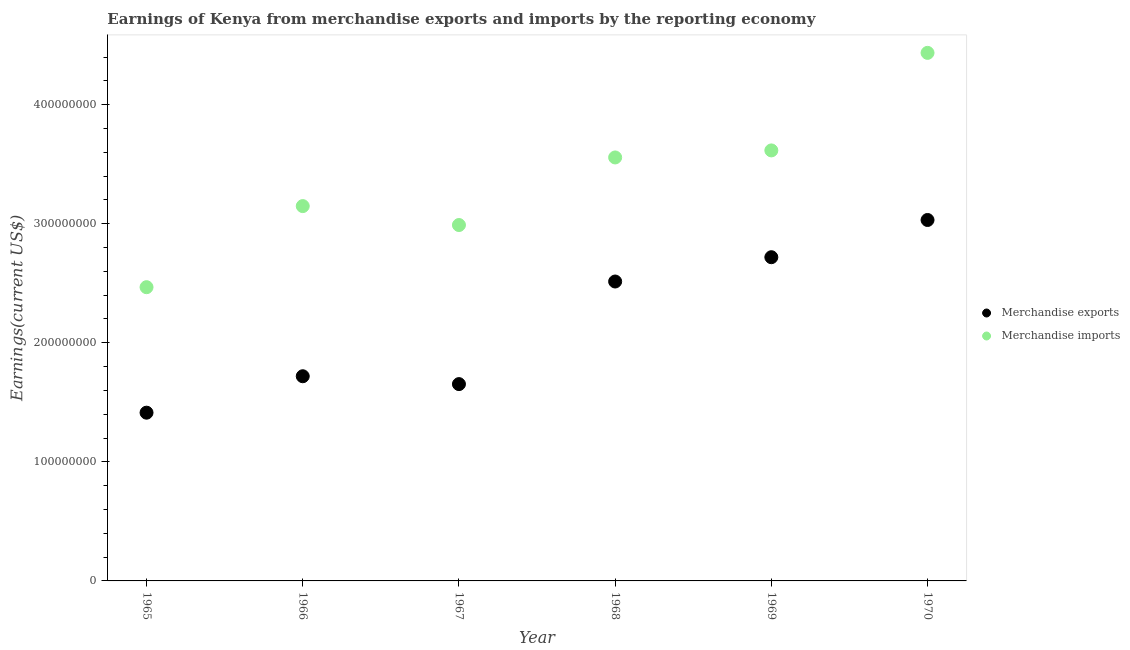Is the number of dotlines equal to the number of legend labels?
Ensure brevity in your answer.  Yes. What is the earnings from merchandise imports in 1965?
Give a very brief answer. 2.47e+08. Across all years, what is the maximum earnings from merchandise exports?
Keep it short and to the point. 3.03e+08. Across all years, what is the minimum earnings from merchandise imports?
Provide a short and direct response. 2.47e+08. In which year was the earnings from merchandise exports maximum?
Keep it short and to the point. 1970. In which year was the earnings from merchandise imports minimum?
Give a very brief answer. 1965. What is the total earnings from merchandise exports in the graph?
Keep it short and to the point. 1.30e+09. What is the difference between the earnings from merchandise imports in 1968 and that in 1970?
Provide a short and direct response. -8.78e+07. What is the difference between the earnings from merchandise imports in 1966 and the earnings from merchandise exports in 1965?
Make the answer very short. 1.74e+08. What is the average earnings from merchandise exports per year?
Offer a very short reply. 2.17e+08. In the year 1966, what is the difference between the earnings from merchandise exports and earnings from merchandise imports?
Offer a very short reply. -1.43e+08. In how many years, is the earnings from merchandise exports greater than 140000000 US$?
Provide a short and direct response. 6. What is the ratio of the earnings from merchandise exports in 1965 to that in 1966?
Give a very brief answer. 0.82. Is the earnings from merchandise imports in 1967 less than that in 1970?
Keep it short and to the point. Yes. What is the difference between the highest and the second highest earnings from merchandise exports?
Give a very brief answer. 3.13e+07. What is the difference between the highest and the lowest earnings from merchandise imports?
Keep it short and to the point. 1.97e+08. In how many years, is the earnings from merchandise imports greater than the average earnings from merchandise imports taken over all years?
Your answer should be very brief. 3. Does the earnings from merchandise imports monotonically increase over the years?
Offer a terse response. No. How many dotlines are there?
Offer a terse response. 2. What is the difference between two consecutive major ticks on the Y-axis?
Your answer should be very brief. 1.00e+08. Are the values on the major ticks of Y-axis written in scientific E-notation?
Provide a succinct answer. No. What is the title of the graph?
Your answer should be very brief. Earnings of Kenya from merchandise exports and imports by the reporting economy. What is the label or title of the Y-axis?
Ensure brevity in your answer.  Earnings(current US$). What is the Earnings(current US$) of Merchandise exports in 1965?
Offer a very short reply. 1.41e+08. What is the Earnings(current US$) of Merchandise imports in 1965?
Make the answer very short. 2.47e+08. What is the Earnings(current US$) in Merchandise exports in 1966?
Give a very brief answer. 1.72e+08. What is the Earnings(current US$) in Merchandise imports in 1966?
Your answer should be compact. 3.15e+08. What is the Earnings(current US$) in Merchandise exports in 1967?
Provide a succinct answer. 1.65e+08. What is the Earnings(current US$) of Merchandise imports in 1967?
Offer a terse response. 2.99e+08. What is the Earnings(current US$) of Merchandise exports in 1968?
Offer a very short reply. 2.51e+08. What is the Earnings(current US$) of Merchandise imports in 1968?
Your answer should be compact. 3.56e+08. What is the Earnings(current US$) of Merchandise exports in 1969?
Ensure brevity in your answer.  2.72e+08. What is the Earnings(current US$) in Merchandise imports in 1969?
Give a very brief answer. 3.62e+08. What is the Earnings(current US$) in Merchandise exports in 1970?
Ensure brevity in your answer.  3.03e+08. What is the Earnings(current US$) in Merchandise imports in 1970?
Offer a very short reply. 4.43e+08. Across all years, what is the maximum Earnings(current US$) of Merchandise exports?
Provide a succinct answer. 3.03e+08. Across all years, what is the maximum Earnings(current US$) in Merchandise imports?
Provide a short and direct response. 4.43e+08. Across all years, what is the minimum Earnings(current US$) in Merchandise exports?
Your answer should be compact. 1.41e+08. Across all years, what is the minimum Earnings(current US$) in Merchandise imports?
Provide a succinct answer. 2.47e+08. What is the total Earnings(current US$) in Merchandise exports in the graph?
Ensure brevity in your answer.  1.30e+09. What is the total Earnings(current US$) of Merchandise imports in the graph?
Keep it short and to the point. 2.02e+09. What is the difference between the Earnings(current US$) in Merchandise exports in 1965 and that in 1966?
Provide a succinct answer. -3.06e+07. What is the difference between the Earnings(current US$) of Merchandise imports in 1965 and that in 1966?
Your answer should be compact. -6.81e+07. What is the difference between the Earnings(current US$) of Merchandise exports in 1965 and that in 1967?
Provide a short and direct response. -2.40e+07. What is the difference between the Earnings(current US$) in Merchandise imports in 1965 and that in 1967?
Give a very brief answer. -5.22e+07. What is the difference between the Earnings(current US$) of Merchandise exports in 1965 and that in 1968?
Keep it short and to the point. -1.10e+08. What is the difference between the Earnings(current US$) of Merchandise imports in 1965 and that in 1968?
Your response must be concise. -1.09e+08. What is the difference between the Earnings(current US$) of Merchandise exports in 1965 and that in 1969?
Your answer should be very brief. -1.31e+08. What is the difference between the Earnings(current US$) of Merchandise imports in 1965 and that in 1969?
Ensure brevity in your answer.  -1.15e+08. What is the difference between the Earnings(current US$) in Merchandise exports in 1965 and that in 1970?
Make the answer very short. -1.62e+08. What is the difference between the Earnings(current US$) of Merchandise imports in 1965 and that in 1970?
Your response must be concise. -1.97e+08. What is the difference between the Earnings(current US$) of Merchandise exports in 1966 and that in 1967?
Give a very brief answer. 6.60e+06. What is the difference between the Earnings(current US$) in Merchandise imports in 1966 and that in 1967?
Give a very brief answer. 1.59e+07. What is the difference between the Earnings(current US$) of Merchandise exports in 1966 and that in 1968?
Provide a short and direct response. -7.96e+07. What is the difference between the Earnings(current US$) of Merchandise imports in 1966 and that in 1968?
Your response must be concise. -4.09e+07. What is the difference between the Earnings(current US$) in Merchandise exports in 1966 and that in 1969?
Make the answer very short. -1.00e+08. What is the difference between the Earnings(current US$) in Merchandise imports in 1966 and that in 1969?
Make the answer very short. -4.68e+07. What is the difference between the Earnings(current US$) of Merchandise exports in 1966 and that in 1970?
Ensure brevity in your answer.  -1.31e+08. What is the difference between the Earnings(current US$) of Merchandise imports in 1966 and that in 1970?
Your response must be concise. -1.29e+08. What is the difference between the Earnings(current US$) of Merchandise exports in 1967 and that in 1968?
Offer a terse response. -8.62e+07. What is the difference between the Earnings(current US$) of Merchandise imports in 1967 and that in 1968?
Offer a very short reply. -5.68e+07. What is the difference between the Earnings(current US$) of Merchandise exports in 1967 and that in 1969?
Make the answer very short. -1.07e+08. What is the difference between the Earnings(current US$) of Merchandise imports in 1967 and that in 1969?
Offer a very short reply. -6.27e+07. What is the difference between the Earnings(current US$) of Merchandise exports in 1967 and that in 1970?
Offer a very short reply. -1.38e+08. What is the difference between the Earnings(current US$) of Merchandise imports in 1967 and that in 1970?
Your response must be concise. -1.45e+08. What is the difference between the Earnings(current US$) in Merchandise exports in 1968 and that in 1969?
Provide a short and direct response. -2.04e+07. What is the difference between the Earnings(current US$) of Merchandise imports in 1968 and that in 1969?
Provide a succinct answer. -5.91e+06. What is the difference between the Earnings(current US$) of Merchandise exports in 1968 and that in 1970?
Your response must be concise. -5.17e+07. What is the difference between the Earnings(current US$) of Merchandise imports in 1968 and that in 1970?
Keep it short and to the point. -8.78e+07. What is the difference between the Earnings(current US$) of Merchandise exports in 1969 and that in 1970?
Keep it short and to the point. -3.13e+07. What is the difference between the Earnings(current US$) in Merchandise imports in 1969 and that in 1970?
Your answer should be compact. -8.19e+07. What is the difference between the Earnings(current US$) of Merchandise exports in 1965 and the Earnings(current US$) of Merchandise imports in 1966?
Your answer should be compact. -1.74e+08. What is the difference between the Earnings(current US$) of Merchandise exports in 1965 and the Earnings(current US$) of Merchandise imports in 1967?
Give a very brief answer. -1.58e+08. What is the difference between the Earnings(current US$) of Merchandise exports in 1965 and the Earnings(current US$) of Merchandise imports in 1968?
Make the answer very short. -2.14e+08. What is the difference between the Earnings(current US$) in Merchandise exports in 1965 and the Earnings(current US$) in Merchandise imports in 1969?
Ensure brevity in your answer.  -2.20e+08. What is the difference between the Earnings(current US$) of Merchandise exports in 1965 and the Earnings(current US$) of Merchandise imports in 1970?
Your answer should be very brief. -3.02e+08. What is the difference between the Earnings(current US$) in Merchandise exports in 1966 and the Earnings(current US$) in Merchandise imports in 1967?
Your response must be concise. -1.27e+08. What is the difference between the Earnings(current US$) of Merchandise exports in 1966 and the Earnings(current US$) of Merchandise imports in 1968?
Provide a short and direct response. -1.84e+08. What is the difference between the Earnings(current US$) of Merchandise exports in 1966 and the Earnings(current US$) of Merchandise imports in 1969?
Provide a succinct answer. -1.90e+08. What is the difference between the Earnings(current US$) of Merchandise exports in 1966 and the Earnings(current US$) of Merchandise imports in 1970?
Your answer should be very brief. -2.72e+08. What is the difference between the Earnings(current US$) of Merchandise exports in 1967 and the Earnings(current US$) of Merchandise imports in 1968?
Make the answer very short. -1.90e+08. What is the difference between the Earnings(current US$) in Merchandise exports in 1967 and the Earnings(current US$) in Merchandise imports in 1969?
Keep it short and to the point. -1.96e+08. What is the difference between the Earnings(current US$) in Merchandise exports in 1967 and the Earnings(current US$) in Merchandise imports in 1970?
Your response must be concise. -2.78e+08. What is the difference between the Earnings(current US$) in Merchandise exports in 1968 and the Earnings(current US$) in Merchandise imports in 1969?
Your response must be concise. -1.10e+08. What is the difference between the Earnings(current US$) of Merchandise exports in 1968 and the Earnings(current US$) of Merchandise imports in 1970?
Ensure brevity in your answer.  -1.92e+08. What is the difference between the Earnings(current US$) of Merchandise exports in 1969 and the Earnings(current US$) of Merchandise imports in 1970?
Provide a short and direct response. -1.72e+08. What is the average Earnings(current US$) of Merchandise exports per year?
Give a very brief answer. 2.17e+08. What is the average Earnings(current US$) of Merchandise imports per year?
Provide a succinct answer. 3.37e+08. In the year 1965, what is the difference between the Earnings(current US$) in Merchandise exports and Earnings(current US$) in Merchandise imports?
Keep it short and to the point. -1.05e+08. In the year 1966, what is the difference between the Earnings(current US$) in Merchandise exports and Earnings(current US$) in Merchandise imports?
Offer a very short reply. -1.43e+08. In the year 1967, what is the difference between the Earnings(current US$) of Merchandise exports and Earnings(current US$) of Merchandise imports?
Offer a very short reply. -1.34e+08. In the year 1968, what is the difference between the Earnings(current US$) of Merchandise exports and Earnings(current US$) of Merchandise imports?
Ensure brevity in your answer.  -1.04e+08. In the year 1969, what is the difference between the Earnings(current US$) of Merchandise exports and Earnings(current US$) of Merchandise imports?
Provide a short and direct response. -8.97e+07. In the year 1970, what is the difference between the Earnings(current US$) in Merchandise exports and Earnings(current US$) in Merchandise imports?
Give a very brief answer. -1.40e+08. What is the ratio of the Earnings(current US$) in Merchandise exports in 1965 to that in 1966?
Offer a terse response. 0.82. What is the ratio of the Earnings(current US$) in Merchandise imports in 1965 to that in 1966?
Your answer should be compact. 0.78. What is the ratio of the Earnings(current US$) in Merchandise exports in 1965 to that in 1967?
Offer a terse response. 0.85. What is the ratio of the Earnings(current US$) of Merchandise imports in 1965 to that in 1967?
Your answer should be compact. 0.83. What is the ratio of the Earnings(current US$) in Merchandise exports in 1965 to that in 1968?
Provide a succinct answer. 0.56. What is the ratio of the Earnings(current US$) of Merchandise imports in 1965 to that in 1968?
Your answer should be compact. 0.69. What is the ratio of the Earnings(current US$) of Merchandise exports in 1965 to that in 1969?
Offer a very short reply. 0.52. What is the ratio of the Earnings(current US$) in Merchandise imports in 1965 to that in 1969?
Offer a terse response. 0.68. What is the ratio of the Earnings(current US$) of Merchandise exports in 1965 to that in 1970?
Offer a very short reply. 0.47. What is the ratio of the Earnings(current US$) of Merchandise imports in 1965 to that in 1970?
Your answer should be very brief. 0.56. What is the ratio of the Earnings(current US$) in Merchandise exports in 1966 to that in 1967?
Ensure brevity in your answer.  1.04. What is the ratio of the Earnings(current US$) in Merchandise imports in 1966 to that in 1967?
Ensure brevity in your answer.  1.05. What is the ratio of the Earnings(current US$) in Merchandise exports in 1966 to that in 1968?
Offer a terse response. 0.68. What is the ratio of the Earnings(current US$) of Merchandise imports in 1966 to that in 1968?
Your response must be concise. 0.89. What is the ratio of the Earnings(current US$) in Merchandise exports in 1966 to that in 1969?
Your answer should be compact. 0.63. What is the ratio of the Earnings(current US$) in Merchandise imports in 1966 to that in 1969?
Keep it short and to the point. 0.87. What is the ratio of the Earnings(current US$) of Merchandise exports in 1966 to that in 1970?
Your answer should be very brief. 0.57. What is the ratio of the Earnings(current US$) of Merchandise imports in 1966 to that in 1970?
Keep it short and to the point. 0.71. What is the ratio of the Earnings(current US$) in Merchandise exports in 1967 to that in 1968?
Keep it short and to the point. 0.66. What is the ratio of the Earnings(current US$) of Merchandise imports in 1967 to that in 1968?
Provide a succinct answer. 0.84. What is the ratio of the Earnings(current US$) in Merchandise exports in 1967 to that in 1969?
Provide a short and direct response. 0.61. What is the ratio of the Earnings(current US$) of Merchandise imports in 1967 to that in 1969?
Ensure brevity in your answer.  0.83. What is the ratio of the Earnings(current US$) in Merchandise exports in 1967 to that in 1970?
Provide a short and direct response. 0.55. What is the ratio of the Earnings(current US$) in Merchandise imports in 1967 to that in 1970?
Make the answer very short. 0.67. What is the ratio of the Earnings(current US$) in Merchandise exports in 1968 to that in 1969?
Make the answer very short. 0.92. What is the ratio of the Earnings(current US$) in Merchandise imports in 1968 to that in 1969?
Give a very brief answer. 0.98. What is the ratio of the Earnings(current US$) in Merchandise exports in 1968 to that in 1970?
Your response must be concise. 0.83. What is the ratio of the Earnings(current US$) of Merchandise imports in 1968 to that in 1970?
Provide a succinct answer. 0.8. What is the ratio of the Earnings(current US$) in Merchandise exports in 1969 to that in 1970?
Provide a short and direct response. 0.9. What is the ratio of the Earnings(current US$) in Merchandise imports in 1969 to that in 1970?
Your answer should be very brief. 0.82. What is the difference between the highest and the second highest Earnings(current US$) in Merchandise exports?
Offer a terse response. 3.13e+07. What is the difference between the highest and the second highest Earnings(current US$) in Merchandise imports?
Provide a short and direct response. 8.19e+07. What is the difference between the highest and the lowest Earnings(current US$) in Merchandise exports?
Your answer should be very brief. 1.62e+08. What is the difference between the highest and the lowest Earnings(current US$) of Merchandise imports?
Make the answer very short. 1.97e+08. 